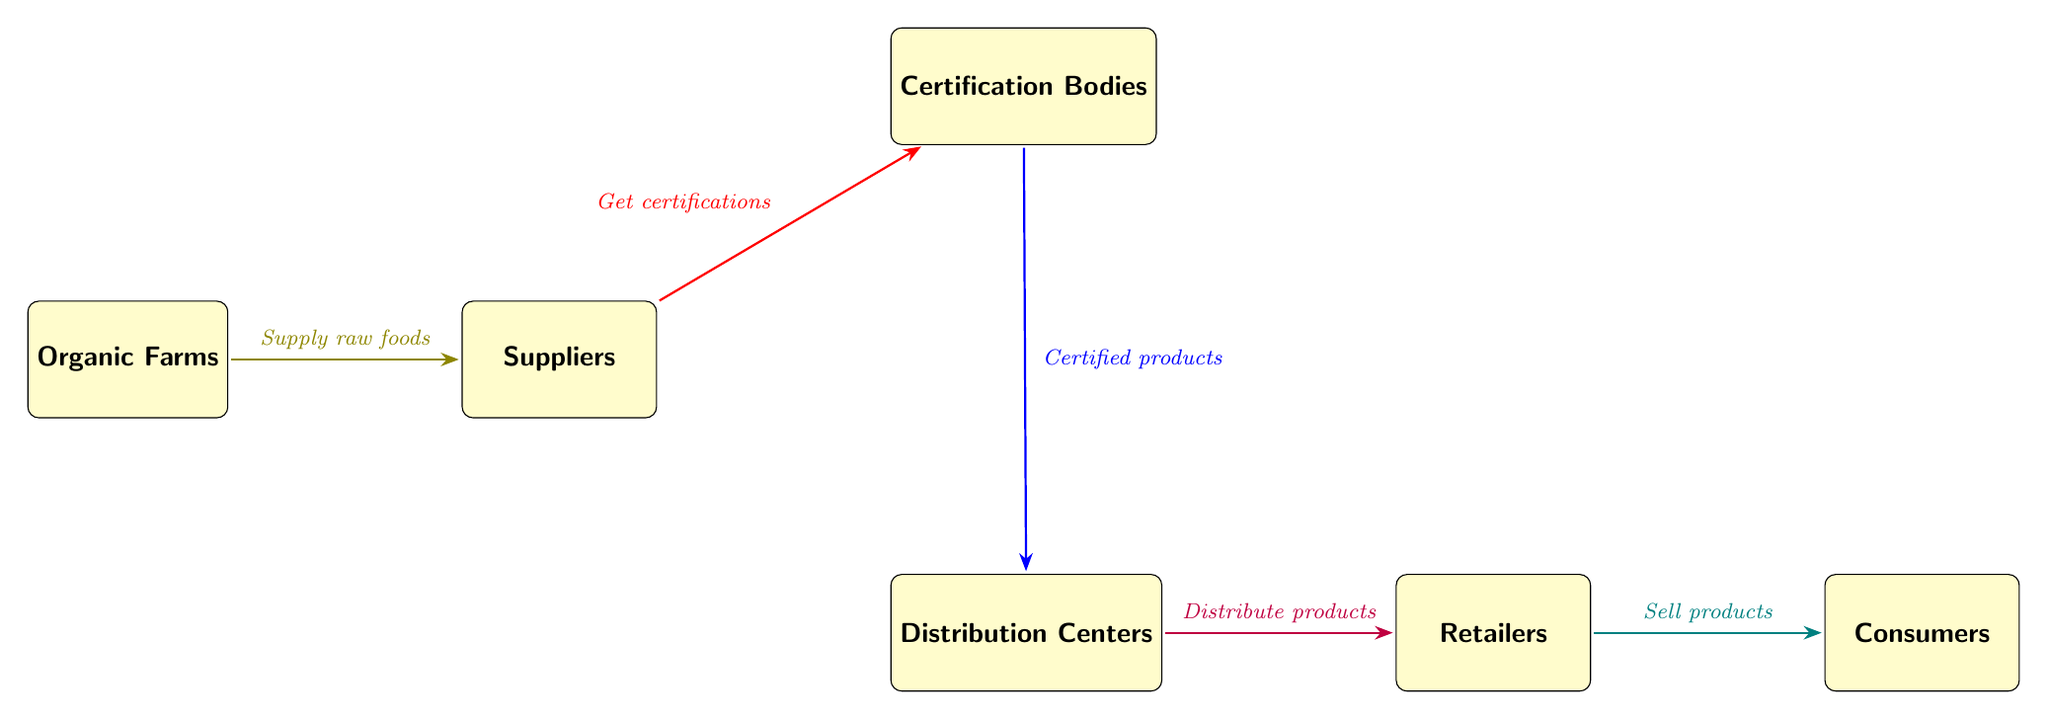What are the nodes in this diagram? The diagram includes six distinct nodes: Organic Farms, Suppliers, Certification Bodies, Distribution Centers, Retailers, and Consumers. Each represents a critical part of the food chain.
Answer: Organic Farms, Suppliers, Certification Bodies, Distribution Centers, Retailers, Consumers How many edges are there in the diagram? The diagram contains five edges that represent the flow of products from one node to the next, depicting the relationships in the organic food sourcing and distribution chain.
Answer: 5 What do Suppliers do with products from Organic Farms? Suppliers receive raw foods from Organic Farms, which indicates the initial step in the organic food supply chain.
Answer: Supply raw foods What happens after suppliers get certifications? Once suppliers obtain certifications from Certification Bodies, the next step is that these certified products are sent to Distribution Centers for further processing and distribution.
Answer: Certified products Which node directly sells products to Consumers? The Retailers are responsible for directly selling the organic products to Consumers, making them the last step in the food chain.
Answer: Retailers What process occurs between Certification Bodies and Distribution Centers? The process that happens between these two nodes is that the Certification Bodies provide the certified products that are then distributed to the Distribution Centers.
Answer: Certified products What role does Certification Bodies play in the food chain? Certification Bodies ensure that the products meet quality standards by giving certifications, which verifies that the products are indeed organic and acceptable for sale.
Answer: Get certifications What do Distribution Centers do in the food chain? The Distribution Centers are responsible for distributing the certified products to the Retailers, facilitating the delivery of organic foods to the market.
Answer: Distribute products What is the direction of flow from Retailers to Consumers? The flow from Retailers to Consumers depicts the process where products are sold to the end users, indicating the final stage of the food chain.
Answer: Sell products 